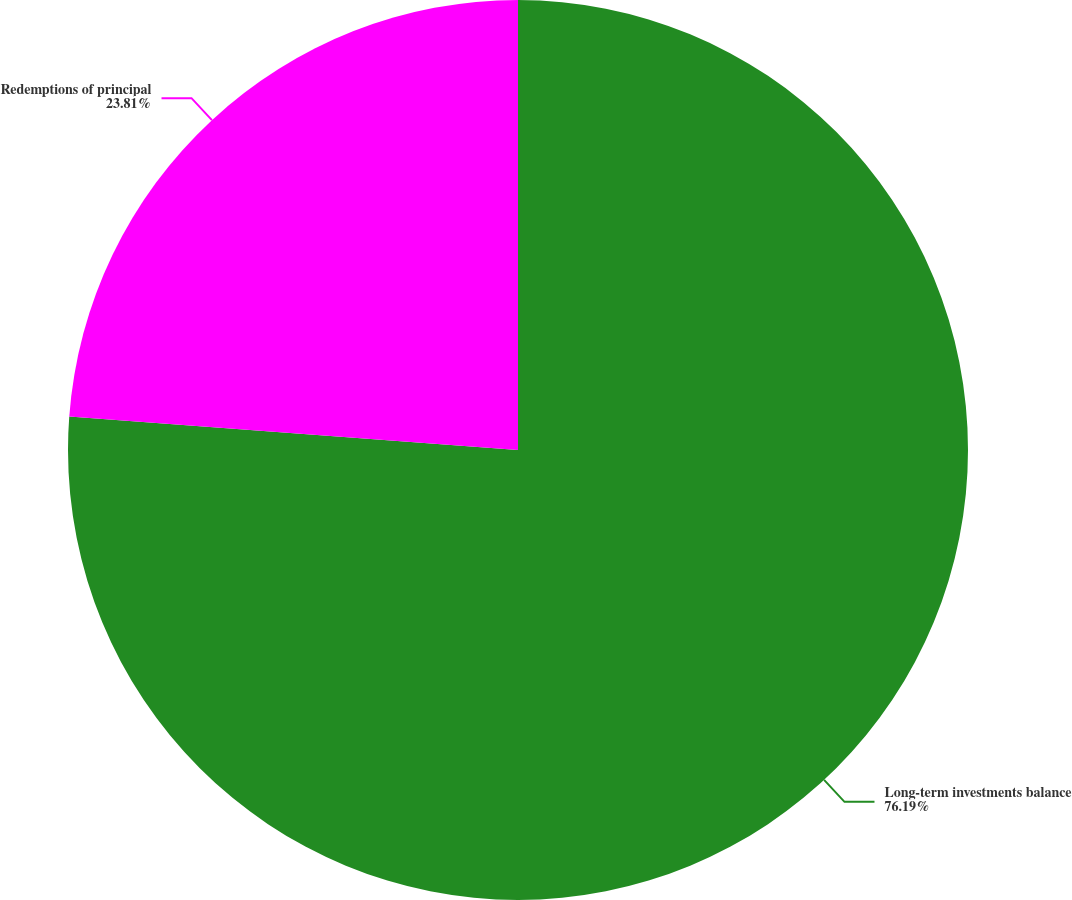Convert chart. <chart><loc_0><loc_0><loc_500><loc_500><pie_chart><fcel>Long-term investments balance<fcel>Redemptions of principal<nl><fcel>76.19%<fcel>23.81%<nl></chart> 